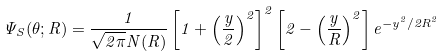<formula> <loc_0><loc_0><loc_500><loc_500>\Psi _ { S } ( \theta ; R ) = \frac { 1 } { \sqrt { 2 \pi } N ( R ) } \left [ 1 + \left ( \frac { y } { 2 } \right ) ^ { 2 } \right ] ^ { 2 } \left [ 2 - \left ( \frac { y } { R } \right ) ^ { 2 } \right ] e ^ { - y ^ { 2 } / 2 R ^ { 2 } }</formula> 